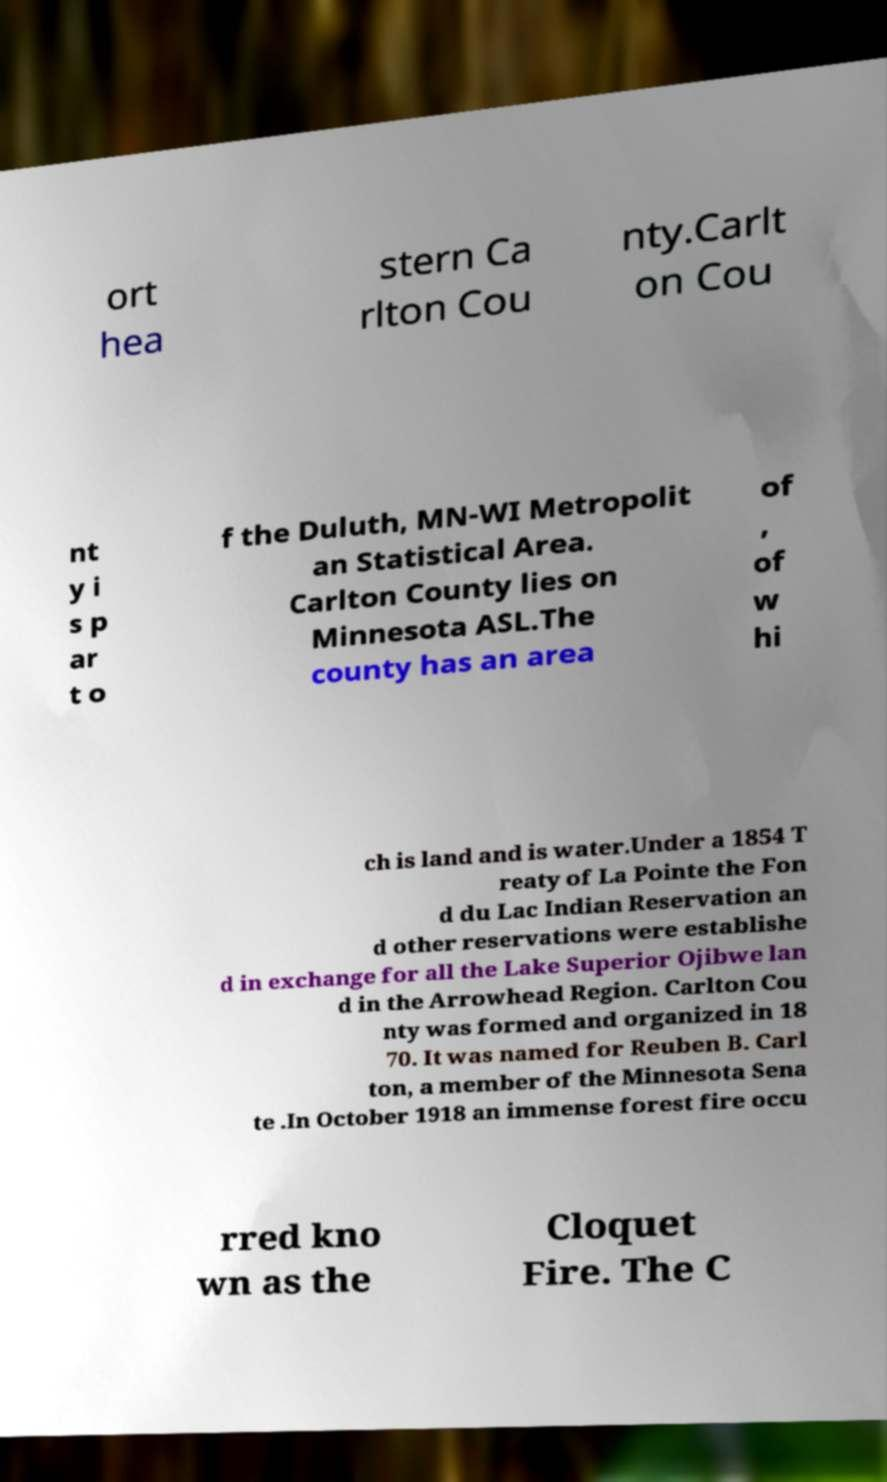Can you accurately transcribe the text from the provided image for me? ort hea stern Ca rlton Cou nty.Carlt on Cou nt y i s p ar t o f the Duluth, MN-WI Metropolit an Statistical Area. Carlton County lies on Minnesota ASL.The county has an area of , of w hi ch is land and is water.Under a 1854 T reaty of La Pointe the Fon d du Lac Indian Reservation an d other reservations were establishe d in exchange for all the Lake Superior Ojibwe lan d in the Arrowhead Region. Carlton Cou nty was formed and organized in 18 70. It was named for Reuben B. Carl ton, a member of the Minnesota Sena te .In October 1918 an immense forest fire occu rred kno wn as the Cloquet Fire. The C 